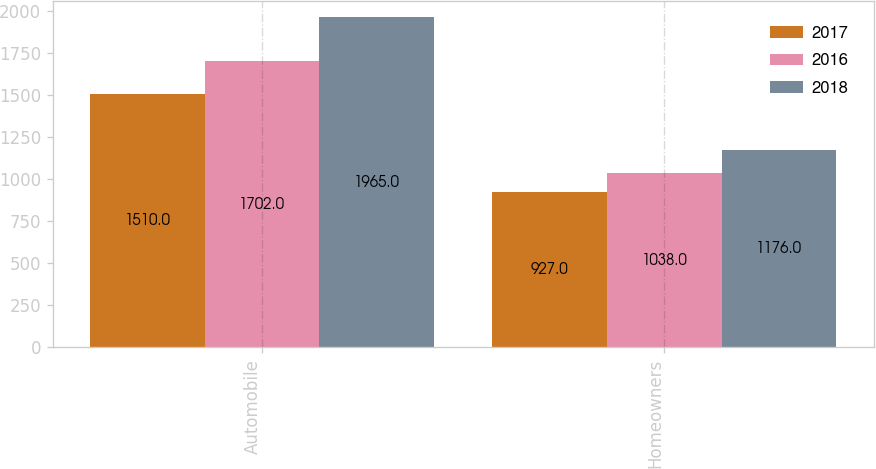Convert chart to OTSL. <chart><loc_0><loc_0><loc_500><loc_500><stacked_bar_chart><ecel><fcel>Automobile<fcel>Homeowners<nl><fcel>2017<fcel>1510<fcel>927<nl><fcel>2016<fcel>1702<fcel>1038<nl><fcel>2018<fcel>1965<fcel>1176<nl></chart> 